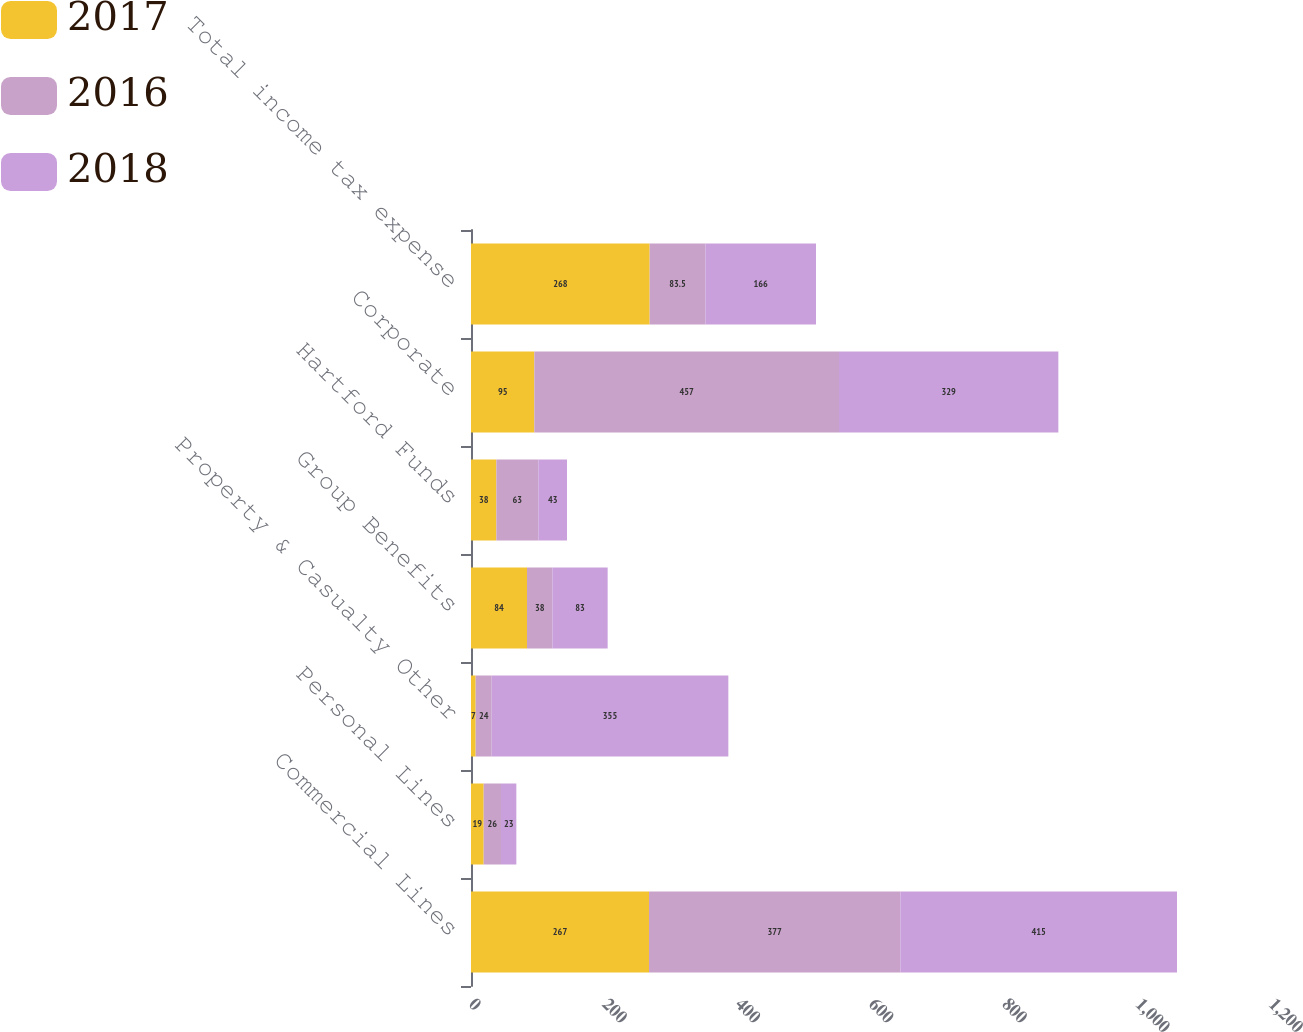Convert chart to OTSL. <chart><loc_0><loc_0><loc_500><loc_500><stacked_bar_chart><ecel><fcel>Commercial Lines<fcel>Personal Lines<fcel>Property & Casualty Other<fcel>Group Benefits<fcel>Hartford Funds<fcel>Corporate<fcel>Total income tax expense<nl><fcel>2017<fcel>267<fcel>19<fcel>7<fcel>84<fcel>38<fcel>95<fcel>268<nl><fcel>2016<fcel>377<fcel>26<fcel>24<fcel>38<fcel>63<fcel>457<fcel>83.5<nl><fcel>2018<fcel>415<fcel>23<fcel>355<fcel>83<fcel>43<fcel>329<fcel>166<nl></chart> 